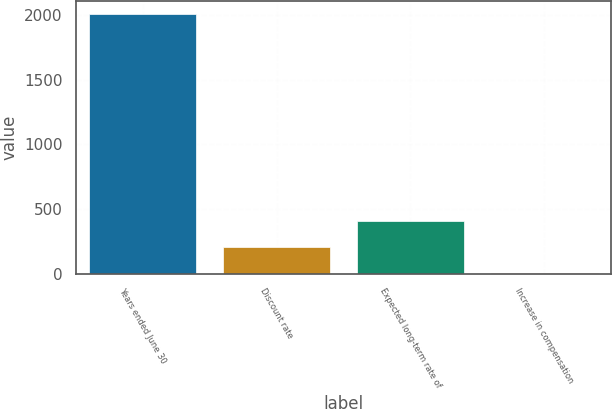Convert chart. <chart><loc_0><loc_0><loc_500><loc_500><bar_chart><fcel>Years ended June 30<fcel>Discount rate<fcel>Expected long-term rate of<fcel>Increase in compensation<nl><fcel>2009<fcel>205.85<fcel>406.2<fcel>5.5<nl></chart> 